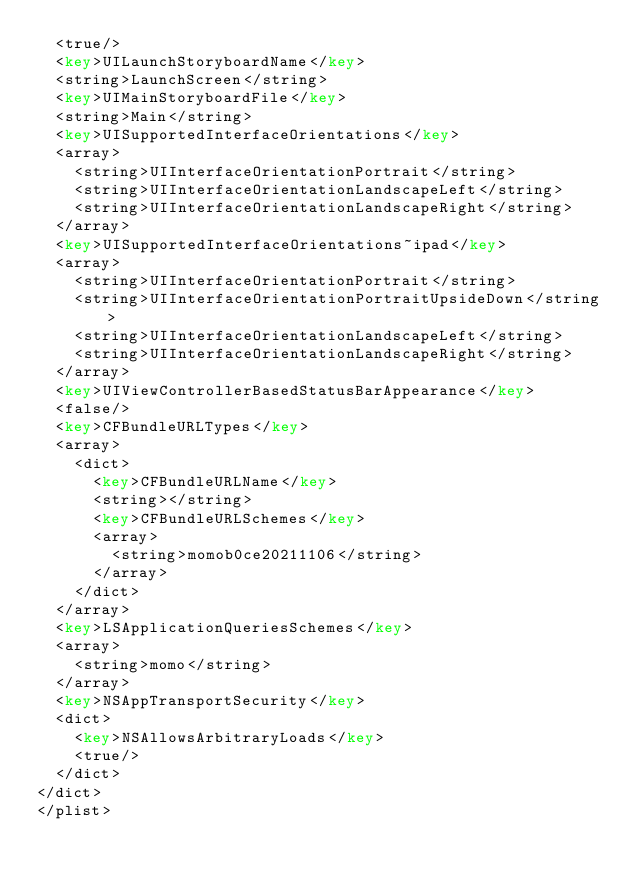<code> <loc_0><loc_0><loc_500><loc_500><_XML_>	<true/>
	<key>UILaunchStoryboardName</key>
	<string>LaunchScreen</string>
	<key>UIMainStoryboardFile</key>
	<string>Main</string>
	<key>UISupportedInterfaceOrientations</key>
	<array>
		<string>UIInterfaceOrientationPortrait</string>
		<string>UIInterfaceOrientationLandscapeLeft</string>
		<string>UIInterfaceOrientationLandscapeRight</string>
	</array>
	<key>UISupportedInterfaceOrientations~ipad</key>
	<array>
		<string>UIInterfaceOrientationPortrait</string>
		<string>UIInterfaceOrientationPortraitUpsideDown</string>
		<string>UIInterfaceOrientationLandscapeLeft</string>
		<string>UIInterfaceOrientationLandscapeRight</string>
	</array>
	<key>UIViewControllerBasedStatusBarAppearance</key>
	<false/>
	<key>CFBundleURLTypes</key>
	<array>
		<dict>
			<key>CFBundleURLName</key>
			<string></string>
			<key>CFBundleURLSchemes</key>
			<array>
				<string>momob0ce20211106</string>
			</array>
		</dict>
	</array>
	<key>LSApplicationQueriesSchemes</key>
	<array>
		<string>momo</string>
	</array>
	<key>NSAppTransportSecurity</key>
	<dict>
		<key>NSAllowsArbitraryLoads</key>
		<true/>
	</dict>
</dict>
</plist>
</code> 